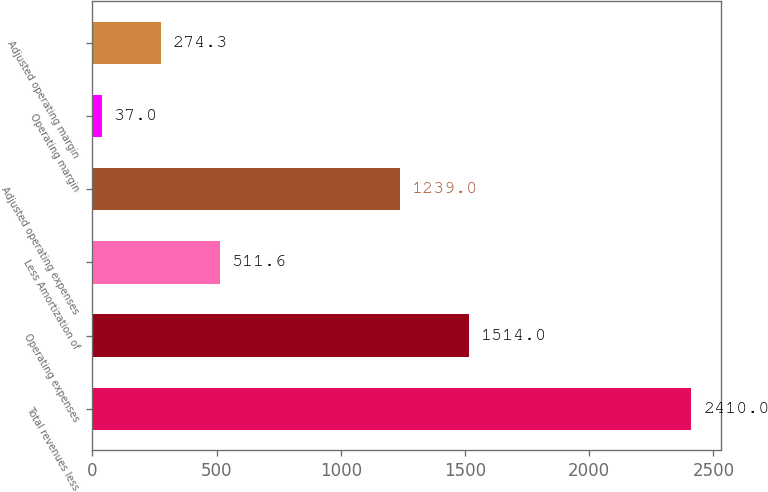<chart> <loc_0><loc_0><loc_500><loc_500><bar_chart><fcel>Total revenues less<fcel>Operating expenses<fcel>Less Amortization of<fcel>Adjusted operating expenses<fcel>Operating margin<fcel>Adjusted operating margin<nl><fcel>2410<fcel>1514<fcel>511.6<fcel>1239<fcel>37<fcel>274.3<nl></chart> 